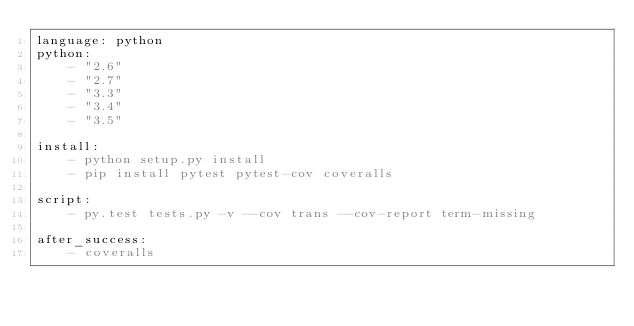Convert code to text. <code><loc_0><loc_0><loc_500><loc_500><_YAML_>language: python
python:
    - "2.6"
    - "2.7"
    - "3.3"
    - "3.4"
    - "3.5"

install:
    - python setup.py install
    - pip install pytest pytest-cov coveralls

script:
    - py.test tests.py -v --cov trans --cov-report term-missing

after_success:
    - coveralls
</code> 